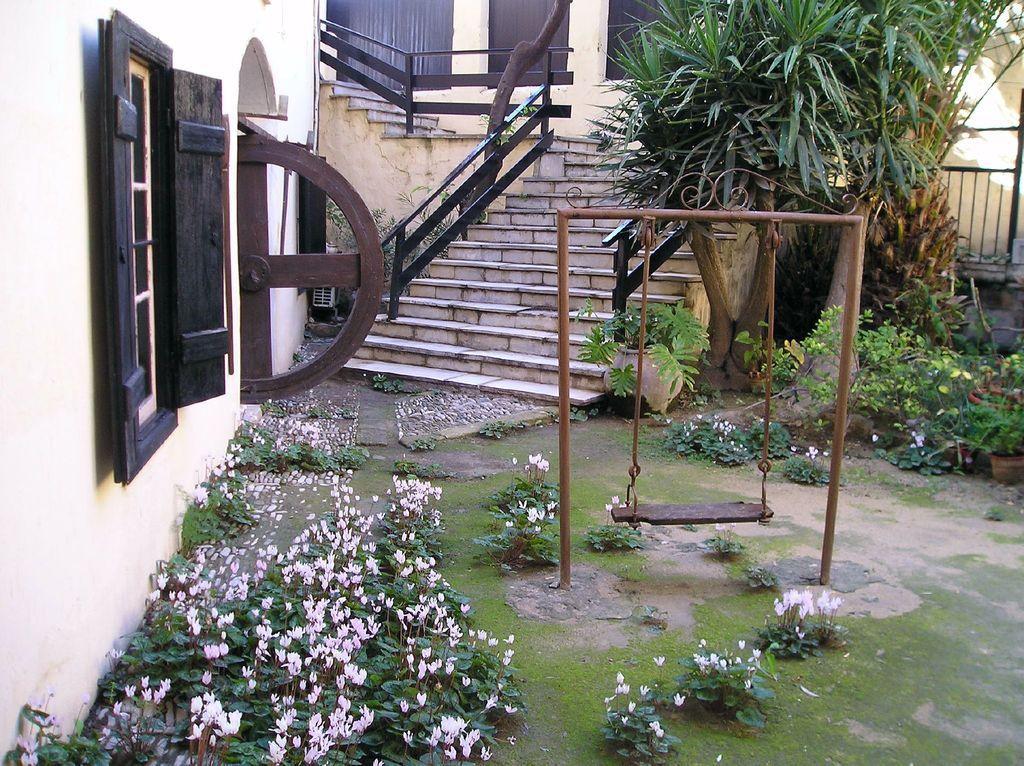Can you describe this image briefly? This picture is clicked outside. In the foreground we can see the plants and the flowers and we can see the metal rods and and a swing. On the left we can see the windows and the staircase, handrail. In the background we can see the plants, metal fence and the windows of the building. 